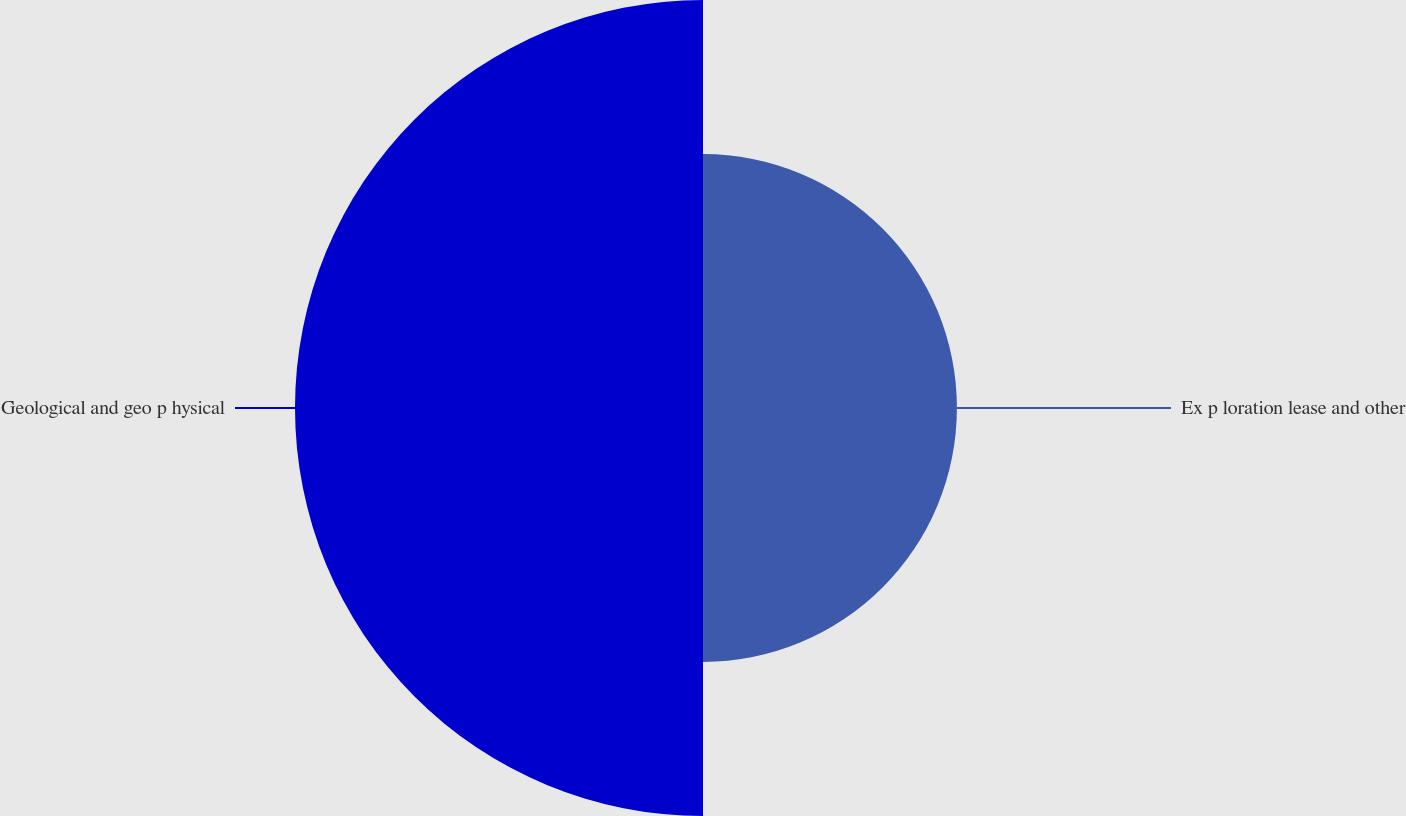Convert chart. <chart><loc_0><loc_0><loc_500><loc_500><pie_chart><fcel>Ex p loration lease and other<fcel>Geological and geo p hysical<nl><fcel>38.36%<fcel>61.64%<nl></chart> 